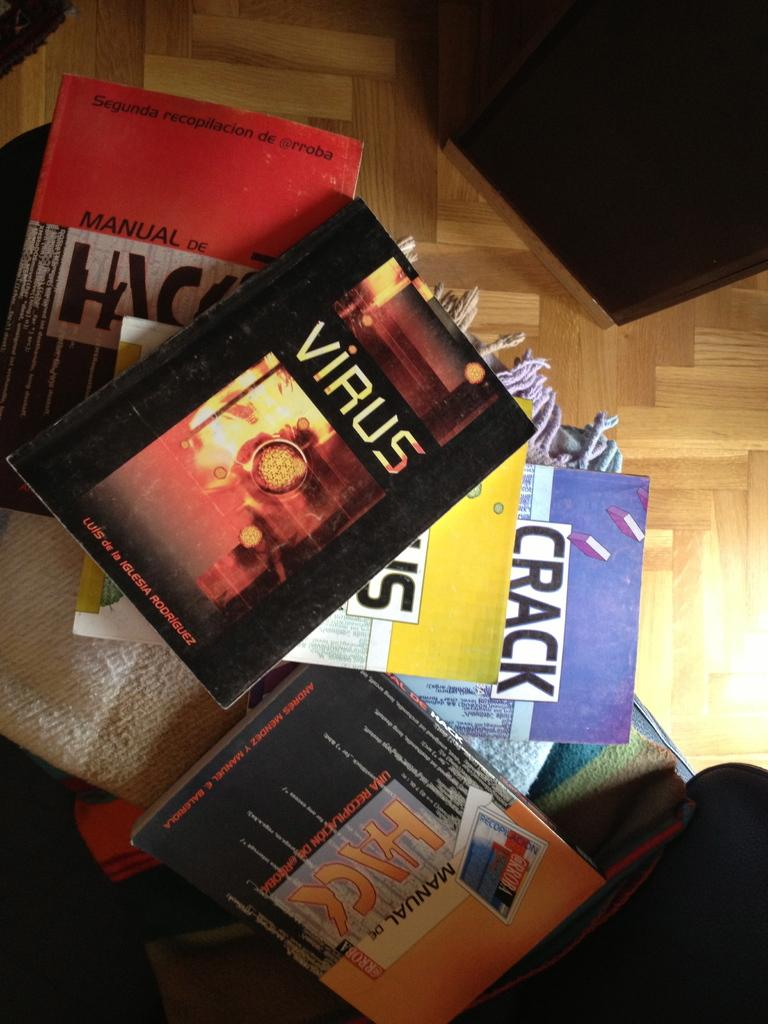Provide a one-sentence caption for the provided image. An arrangement of books lies on a wood floor and features Virus by Iglesia Rodriguez. 